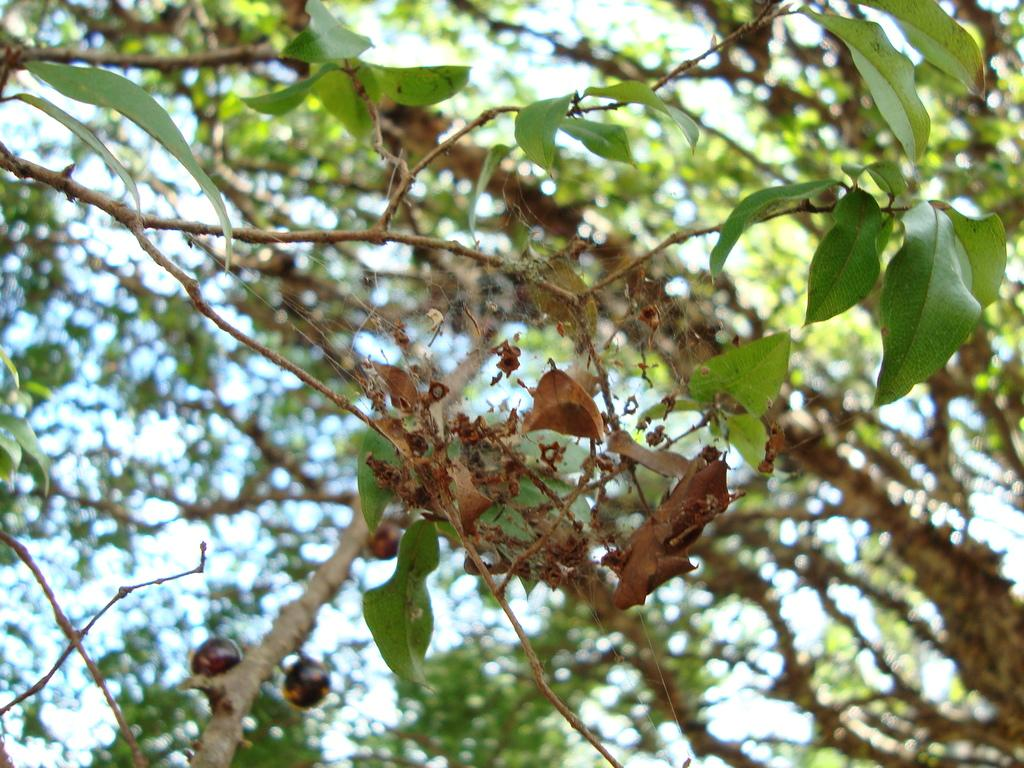What type of plant can be seen in the image? There is a tree in the image. What part of the tree is visible in the image? There is a dry leaf in the image. What type of pest can be seen on the tree in the image? There is no pest visible on the tree in the image. What answer is being provided by the tree in the image? Trees do not provide answers, as they are plants and do not have the ability to communicate in that way. 